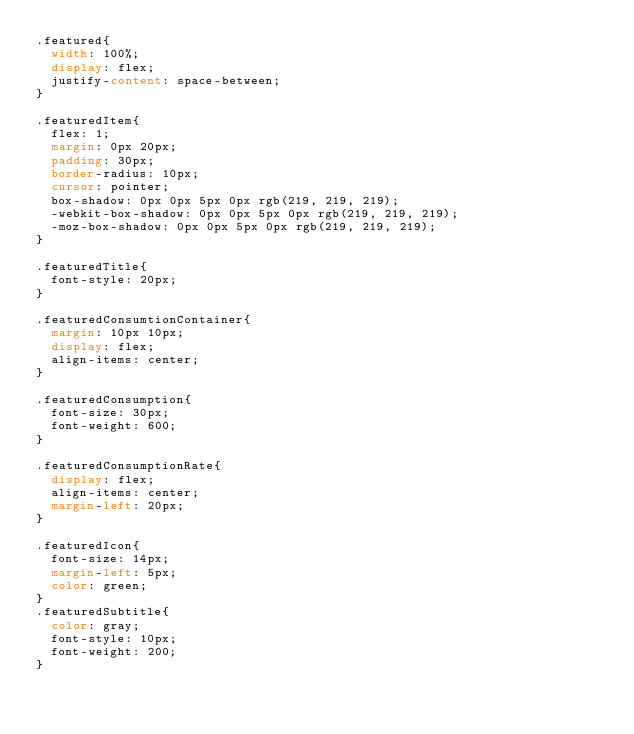Convert code to text. <code><loc_0><loc_0><loc_500><loc_500><_CSS_>.featured{
  width: 100%;
  display: flex;
  justify-content: space-between;
}

.featuredItem{
  flex: 1;
  margin: 0px 20px;
  padding: 30px;
  border-radius: 10px;
  cursor: pointer;
  box-shadow: 0px 0px 5px 0px rgb(219, 219, 219);
  -webkit-box-shadow: 0px 0px 5px 0px rgb(219, 219, 219);
  -moz-box-shadow: 0px 0px 5px 0px rgb(219, 219, 219);
}

.featuredTitle{
  font-style: 20px;
}

.featuredConsumtionContainer{
  margin: 10px 10px;
  display: flex;
  align-items: center;
}

.featuredConsumption{
  font-size: 30px;
  font-weight: 600;
}

.featuredConsumptionRate{
  display: flex;
  align-items: center;
  margin-left: 20px;
}

.featuredIcon{
  font-size: 14px;
  margin-left: 5px;
  color: green;
}
.featuredSubtitle{
  color: gray;
  font-style: 10px;
  font-weight: 200;
}</code> 